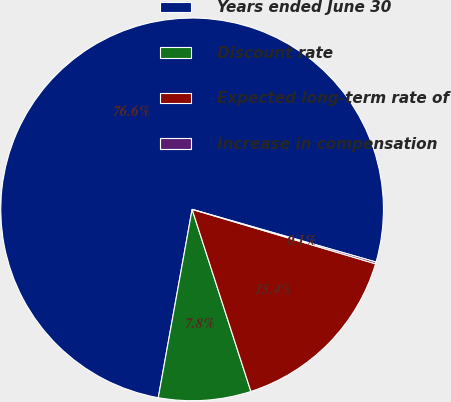Convert chart to OTSL. <chart><loc_0><loc_0><loc_500><loc_500><pie_chart><fcel>Years ended June 30<fcel>Discount rate<fcel>Expected long-term rate of<fcel>Increase in compensation<nl><fcel>76.61%<fcel>7.8%<fcel>15.44%<fcel>0.15%<nl></chart> 